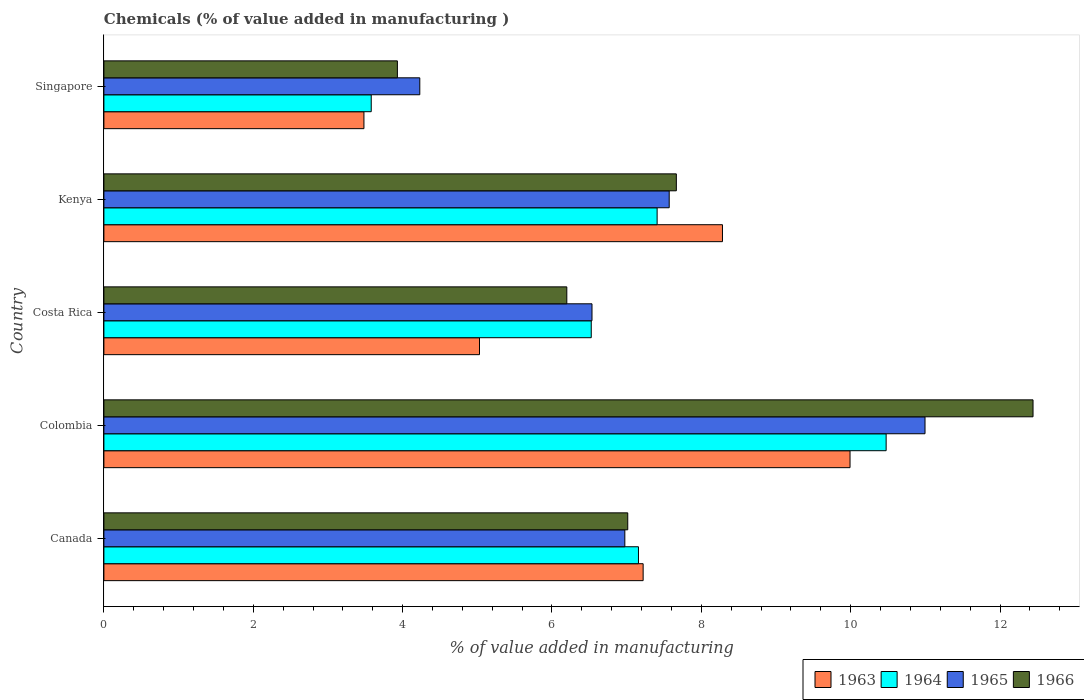How many different coloured bars are there?
Offer a very short reply. 4. How many groups of bars are there?
Make the answer very short. 5. How many bars are there on the 1st tick from the bottom?
Provide a short and direct response. 4. What is the label of the 2nd group of bars from the top?
Provide a succinct answer. Kenya. What is the value added in manufacturing chemicals in 1964 in Canada?
Provide a short and direct response. 7.16. Across all countries, what is the maximum value added in manufacturing chemicals in 1966?
Make the answer very short. 12.44. Across all countries, what is the minimum value added in manufacturing chemicals in 1966?
Your answer should be very brief. 3.93. In which country was the value added in manufacturing chemicals in 1966 minimum?
Your answer should be compact. Singapore. What is the total value added in manufacturing chemicals in 1963 in the graph?
Make the answer very short. 34.01. What is the difference between the value added in manufacturing chemicals in 1963 in Colombia and that in Costa Rica?
Your response must be concise. 4.96. What is the difference between the value added in manufacturing chemicals in 1964 in Costa Rica and the value added in manufacturing chemicals in 1965 in Canada?
Make the answer very short. -0.45. What is the average value added in manufacturing chemicals in 1966 per country?
Your response must be concise. 7.45. What is the difference between the value added in manufacturing chemicals in 1964 and value added in manufacturing chemicals in 1966 in Kenya?
Give a very brief answer. -0.26. In how many countries, is the value added in manufacturing chemicals in 1964 greater than 7.2 %?
Make the answer very short. 2. What is the ratio of the value added in manufacturing chemicals in 1965 in Canada to that in Costa Rica?
Make the answer very short. 1.07. What is the difference between the highest and the second highest value added in manufacturing chemicals in 1966?
Keep it short and to the point. 4.78. What is the difference between the highest and the lowest value added in manufacturing chemicals in 1963?
Ensure brevity in your answer.  6.51. Is the sum of the value added in manufacturing chemicals in 1966 in Canada and Colombia greater than the maximum value added in manufacturing chemicals in 1964 across all countries?
Your answer should be very brief. Yes. Is it the case that in every country, the sum of the value added in manufacturing chemicals in 1964 and value added in manufacturing chemicals in 1966 is greater than the sum of value added in manufacturing chemicals in 1965 and value added in manufacturing chemicals in 1963?
Ensure brevity in your answer.  No. What does the 1st bar from the top in Costa Rica represents?
Offer a terse response. 1966. What does the 4th bar from the bottom in Singapore represents?
Your response must be concise. 1966. Is it the case that in every country, the sum of the value added in manufacturing chemicals in 1965 and value added in manufacturing chemicals in 1964 is greater than the value added in manufacturing chemicals in 1963?
Provide a succinct answer. Yes. Are all the bars in the graph horizontal?
Your response must be concise. Yes. What is the difference between two consecutive major ticks on the X-axis?
Make the answer very short. 2. Are the values on the major ticks of X-axis written in scientific E-notation?
Offer a terse response. No. Does the graph contain grids?
Offer a terse response. No. Where does the legend appear in the graph?
Offer a very short reply. Bottom right. What is the title of the graph?
Provide a succinct answer. Chemicals (% of value added in manufacturing ). Does "2010" appear as one of the legend labels in the graph?
Make the answer very short. No. What is the label or title of the X-axis?
Make the answer very short. % of value added in manufacturing. What is the % of value added in manufacturing in 1963 in Canada?
Provide a short and direct response. 7.22. What is the % of value added in manufacturing of 1964 in Canada?
Provide a short and direct response. 7.16. What is the % of value added in manufacturing of 1965 in Canada?
Ensure brevity in your answer.  6.98. What is the % of value added in manufacturing of 1966 in Canada?
Keep it short and to the point. 7.01. What is the % of value added in manufacturing of 1963 in Colombia?
Your answer should be very brief. 9.99. What is the % of value added in manufacturing of 1964 in Colombia?
Your answer should be very brief. 10.47. What is the % of value added in manufacturing in 1965 in Colombia?
Make the answer very short. 10.99. What is the % of value added in manufacturing in 1966 in Colombia?
Ensure brevity in your answer.  12.44. What is the % of value added in manufacturing in 1963 in Costa Rica?
Offer a terse response. 5.03. What is the % of value added in manufacturing in 1964 in Costa Rica?
Your answer should be compact. 6.53. What is the % of value added in manufacturing in 1965 in Costa Rica?
Provide a succinct answer. 6.54. What is the % of value added in manufacturing of 1966 in Costa Rica?
Keep it short and to the point. 6.2. What is the % of value added in manufacturing of 1963 in Kenya?
Your answer should be very brief. 8.28. What is the % of value added in manufacturing in 1964 in Kenya?
Offer a very short reply. 7.41. What is the % of value added in manufacturing in 1965 in Kenya?
Provide a short and direct response. 7.57. What is the % of value added in manufacturing of 1966 in Kenya?
Keep it short and to the point. 7.67. What is the % of value added in manufacturing in 1963 in Singapore?
Offer a terse response. 3.48. What is the % of value added in manufacturing of 1964 in Singapore?
Your response must be concise. 3.58. What is the % of value added in manufacturing in 1965 in Singapore?
Offer a very short reply. 4.23. What is the % of value added in manufacturing of 1966 in Singapore?
Your response must be concise. 3.93. Across all countries, what is the maximum % of value added in manufacturing of 1963?
Your answer should be compact. 9.99. Across all countries, what is the maximum % of value added in manufacturing of 1964?
Offer a very short reply. 10.47. Across all countries, what is the maximum % of value added in manufacturing in 1965?
Your answer should be very brief. 10.99. Across all countries, what is the maximum % of value added in manufacturing of 1966?
Provide a short and direct response. 12.44. Across all countries, what is the minimum % of value added in manufacturing of 1963?
Offer a very short reply. 3.48. Across all countries, what is the minimum % of value added in manufacturing in 1964?
Provide a succinct answer. 3.58. Across all countries, what is the minimum % of value added in manufacturing of 1965?
Give a very brief answer. 4.23. Across all countries, what is the minimum % of value added in manufacturing of 1966?
Your answer should be very brief. 3.93. What is the total % of value added in manufacturing in 1963 in the graph?
Offer a terse response. 34.01. What is the total % of value added in manufacturing of 1964 in the graph?
Ensure brevity in your answer.  35.15. What is the total % of value added in manufacturing in 1965 in the graph?
Your answer should be compact. 36.31. What is the total % of value added in manufacturing in 1966 in the graph?
Offer a very short reply. 37.25. What is the difference between the % of value added in manufacturing of 1963 in Canada and that in Colombia?
Keep it short and to the point. -2.77. What is the difference between the % of value added in manufacturing of 1964 in Canada and that in Colombia?
Keep it short and to the point. -3.32. What is the difference between the % of value added in manufacturing of 1965 in Canada and that in Colombia?
Offer a terse response. -4.02. What is the difference between the % of value added in manufacturing of 1966 in Canada and that in Colombia?
Offer a very short reply. -5.43. What is the difference between the % of value added in manufacturing of 1963 in Canada and that in Costa Rica?
Offer a very short reply. 2.19. What is the difference between the % of value added in manufacturing of 1964 in Canada and that in Costa Rica?
Make the answer very short. 0.63. What is the difference between the % of value added in manufacturing in 1965 in Canada and that in Costa Rica?
Ensure brevity in your answer.  0.44. What is the difference between the % of value added in manufacturing of 1966 in Canada and that in Costa Rica?
Provide a succinct answer. 0.82. What is the difference between the % of value added in manufacturing in 1963 in Canada and that in Kenya?
Offer a very short reply. -1.06. What is the difference between the % of value added in manufacturing of 1964 in Canada and that in Kenya?
Keep it short and to the point. -0.25. What is the difference between the % of value added in manufacturing of 1965 in Canada and that in Kenya?
Offer a terse response. -0.59. What is the difference between the % of value added in manufacturing of 1966 in Canada and that in Kenya?
Keep it short and to the point. -0.65. What is the difference between the % of value added in manufacturing in 1963 in Canada and that in Singapore?
Keep it short and to the point. 3.74. What is the difference between the % of value added in manufacturing in 1964 in Canada and that in Singapore?
Make the answer very short. 3.58. What is the difference between the % of value added in manufacturing in 1965 in Canada and that in Singapore?
Ensure brevity in your answer.  2.75. What is the difference between the % of value added in manufacturing of 1966 in Canada and that in Singapore?
Make the answer very short. 3.08. What is the difference between the % of value added in manufacturing of 1963 in Colombia and that in Costa Rica?
Your answer should be very brief. 4.96. What is the difference between the % of value added in manufacturing in 1964 in Colombia and that in Costa Rica?
Your answer should be very brief. 3.95. What is the difference between the % of value added in manufacturing in 1965 in Colombia and that in Costa Rica?
Keep it short and to the point. 4.46. What is the difference between the % of value added in manufacturing of 1966 in Colombia and that in Costa Rica?
Give a very brief answer. 6.24. What is the difference between the % of value added in manufacturing in 1963 in Colombia and that in Kenya?
Your answer should be compact. 1.71. What is the difference between the % of value added in manufacturing in 1964 in Colombia and that in Kenya?
Ensure brevity in your answer.  3.07. What is the difference between the % of value added in manufacturing of 1965 in Colombia and that in Kenya?
Offer a very short reply. 3.43. What is the difference between the % of value added in manufacturing of 1966 in Colombia and that in Kenya?
Your response must be concise. 4.78. What is the difference between the % of value added in manufacturing of 1963 in Colombia and that in Singapore?
Provide a succinct answer. 6.51. What is the difference between the % of value added in manufacturing in 1964 in Colombia and that in Singapore?
Your response must be concise. 6.89. What is the difference between the % of value added in manufacturing in 1965 in Colombia and that in Singapore?
Give a very brief answer. 6.76. What is the difference between the % of value added in manufacturing in 1966 in Colombia and that in Singapore?
Keep it short and to the point. 8.51. What is the difference between the % of value added in manufacturing in 1963 in Costa Rica and that in Kenya?
Offer a very short reply. -3.25. What is the difference between the % of value added in manufacturing in 1964 in Costa Rica and that in Kenya?
Your answer should be compact. -0.88. What is the difference between the % of value added in manufacturing in 1965 in Costa Rica and that in Kenya?
Give a very brief answer. -1.03. What is the difference between the % of value added in manufacturing of 1966 in Costa Rica and that in Kenya?
Keep it short and to the point. -1.47. What is the difference between the % of value added in manufacturing in 1963 in Costa Rica and that in Singapore?
Make the answer very short. 1.55. What is the difference between the % of value added in manufacturing of 1964 in Costa Rica and that in Singapore?
Offer a terse response. 2.95. What is the difference between the % of value added in manufacturing in 1965 in Costa Rica and that in Singapore?
Offer a terse response. 2.31. What is the difference between the % of value added in manufacturing of 1966 in Costa Rica and that in Singapore?
Keep it short and to the point. 2.27. What is the difference between the % of value added in manufacturing of 1963 in Kenya and that in Singapore?
Your answer should be compact. 4.8. What is the difference between the % of value added in manufacturing of 1964 in Kenya and that in Singapore?
Provide a succinct answer. 3.83. What is the difference between the % of value added in manufacturing of 1965 in Kenya and that in Singapore?
Make the answer very short. 3.34. What is the difference between the % of value added in manufacturing of 1966 in Kenya and that in Singapore?
Give a very brief answer. 3.74. What is the difference between the % of value added in manufacturing in 1963 in Canada and the % of value added in manufacturing in 1964 in Colombia?
Give a very brief answer. -3.25. What is the difference between the % of value added in manufacturing of 1963 in Canada and the % of value added in manufacturing of 1965 in Colombia?
Provide a succinct answer. -3.77. What is the difference between the % of value added in manufacturing in 1963 in Canada and the % of value added in manufacturing in 1966 in Colombia?
Keep it short and to the point. -5.22. What is the difference between the % of value added in manufacturing of 1964 in Canada and the % of value added in manufacturing of 1965 in Colombia?
Your answer should be compact. -3.84. What is the difference between the % of value added in manufacturing of 1964 in Canada and the % of value added in manufacturing of 1966 in Colombia?
Ensure brevity in your answer.  -5.28. What is the difference between the % of value added in manufacturing of 1965 in Canada and the % of value added in manufacturing of 1966 in Colombia?
Your response must be concise. -5.47. What is the difference between the % of value added in manufacturing in 1963 in Canada and the % of value added in manufacturing in 1964 in Costa Rica?
Provide a short and direct response. 0.69. What is the difference between the % of value added in manufacturing in 1963 in Canada and the % of value added in manufacturing in 1965 in Costa Rica?
Your response must be concise. 0.68. What is the difference between the % of value added in manufacturing of 1963 in Canada and the % of value added in manufacturing of 1966 in Costa Rica?
Your response must be concise. 1.02. What is the difference between the % of value added in manufacturing of 1964 in Canada and the % of value added in manufacturing of 1965 in Costa Rica?
Ensure brevity in your answer.  0.62. What is the difference between the % of value added in manufacturing of 1964 in Canada and the % of value added in manufacturing of 1966 in Costa Rica?
Ensure brevity in your answer.  0.96. What is the difference between the % of value added in manufacturing in 1965 in Canada and the % of value added in manufacturing in 1966 in Costa Rica?
Your answer should be compact. 0.78. What is the difference between the % of value added in manufacturing of 1963 in Canada and the % of value added in manufacturing of 1964 in Kenya?
Your response must be concise. -0.19. What is the difference between the % of value added in manufacturing of 1963 in Canada and the % of value added in manufacturing of 1965 in Kenya?
Provide a short and direct response. -0.35. What is the difference between the % of value added in manufacturing in 1963 in Canada and the % of value added in manufacturing in 1966 in Kenya?
Provide a short and direct response. -0.44. What is the difference between the % of value added in manufacturing of 1964 in Canada and the % of value added in manufacturing of 1965 in Kenya?
Your answer should be very brief. -0.41. What is the difference between the % of value added in manufacturing in 1964 in Canada and the % of value added in manufacturing in 1966 in Kenya?
Keep it short and to the point. -0.51. What is the difference between the % of value added in manufacturing of 1965 in Canada and the % of value added in manufacturing of 1966 in Kenya?
Your answer should be very brief. -0.69. What is the difference between the % of value added in manufacturing of 1963 in Canada and the % of value added in manufacturing of 1964 in Singapore?
Offer a very short reply. 3.64. What is the difference between the % of value added in manufacturing of 1963 in Canada and the % of value added in manufacturing of 1965 in Singapore?
Your answer should be compact. 2.99. What is the difference between the % of value added in manufacturing of 1963 in Canada and the % of value added in manufacturing of 1966 in Singapore?
Provide a short and direct response. 3.29. What is the difference between the % of value added in manufacturing of 1964 in Canada and the % of value added in manufacturing of 1965 in Singapore?
Provide a succinct answer. 2.93. What is the difference between the % of value added in manufacturing of 1964 in Canada and the % of value added in manufacturing of 1966 in Singapore?
Your response must be concise. 3.23. What is the difference between the % of value added in manufacturing in 1965 in Canada and the % of value added in manufacturing in 1966 in Singapore?
Make the answer very short. 3.05. What is the difference between the % of value added in manufacturing in 1963 in Colombia and the % of value added in manufacturing in 1964 in Costa Rica?
Offer a terse response. 3.47. What is the difference between the % of value added in manufacturing in 1963 in Colombia and the % of value added in manufacturing in 1965 in Costa Rica?
Ensure brevity in your answer.  3.46. What is the difference between the % of value added in manufacturing in 1963 in Colombia and the % of value added in manufacturing in 1966 in Costa Rica?
Offer a very short reply. 3.79. What is the difference between the % of value added in manufacturing of 1964 in Colombia and the % of value added in manufacturing of 1965 in Costa Rica?
Offer a very short reply. 3.94. What is the difference between the % of value added in manufacturing of 1964 in Colombia and the % of value added in manufacturing of 1966 in Costa Rica?
Give a very brief answer. 4.28. What is the difference between the % of value added in manufacturing in 1965 in Colombia and the % of value added in manufacturing in 1966 in Costa Rica?
Ensure brevity in your answer.  4.8. What is the difference between the % of value added in manufacturing in 1963 in Colombia and the % of value added in manufacturing in 1964 in Kenya?
Provide a short and direct response. 2.58. What is the difference between the % of value added in manufacturing in 1963 in Colombia and the % of value added in manufacturing in 1965 in Kenya?
Provide a succinct answer. 2.42. What is the difference between the % of value added in manufacturing of 1963 in Colombia and the % of value added in manufacturing of 1966 in Kenya?
Provide a succinct answer. 2.33. What is the difference between the % of value added in manufacturing in 1964 in Colombia and the % of value added in manufacturing in 1965 in Kenya?
Give a very brief answer. 2.9. What is the difference between the % of value added in manufacturing of 1964 in Colombia and the % of value added in manufacturing of 1966 in Kenya?
Keep it short and to the point. 2.81. What is the difference between the % of value added in manufacturing of 1965 in Colombia and the % of value added in manufacturing of 1966 in Kenya?
Keep it short and to the point. 3.33. What is the difference between the % of value added in manufacturing in 1963 in Colombia and the % of value added in manufacturing in 1964 in Singapore?
Keep it short and to the point. 6.41. What is the difference between the % of value added in manufacturing in 1963 in Colombia and the % of value added in manufacturing in 1965 in Singapore?
Ensure brevity in your answer.  5.76. What is the difference between the % of value added in manufacturing in 1963 in Colombia and the % of value added in manufacturing in 1966 in Singapore?
Your answer should be very brief. 6.06. What is the difference between the % of value added in manufacturing of 1964 in Colombia and the % of value added in manufacturing of 1965 in Singapore?
Ensure brevity in your answer.  6.24. What is the difference between the % of value added in manufacturing in 1964 in Colombia and the % of value added in manufacturing in 1966 in Singapore?
Ensure brevity in your answer.  6.54. What is the difference between the % of value added in manufacturing in 1965 in Colombia and the % of value added in manufacturing in 1966 in Singapore?
Provide a succinct answer. 7.07. What is the difference between the % of value added in manufacturing in 1963 in Costa Rica and the % of value added in manufacturing in 1964 in Kenya?
Provide a short and direct response. -2.38. What is the difference between the % of value added in manufacturing of 1963 in Costa Rica and the % of value added in manufacturing of 1965 in Kenya?
Give a very brief answer. -2.54. What is the difference between the % of value added in manufacturing in 1963 in Costa Rica and the % of value added in manufacturing in 1966 in Kenya?
Your response must be concise. -2.64. What is the difference between the % of value added in manufacturing of 1964 in Costa Rica and the % of value added in manufacturing of 1965 in Kenya?
Ensure brevity in your answer.  -1.04. What is the difference between the % of value added in manufacturing in 1964 in Costa Rica and the % of value added in manufacturing in 1966 in Kenya?
Ensure brevity in your answer.  -1.14. What is the difference between the % of value added in manufacturing in 1965 in Costa Rica and the % of value added in manufacturing in 1966 in Kenya?
Provide a succinct answer. -1.13. What is the difference between the % of value added in manufacturing in 1963 in Costa Rica and the % of value added in manufacturing in 1964 in Singapore?
Offer a very short reply. 1.45. What is the difference between the % of value added in manufacturing in 1963 in Costa Rica and the % of value added in manufacturing in 1965 in Singapore?
Offer a very short reply. 0.8. What is the difference between the % of value added in manufacturing in 1963 in Costa Rica and the % of value added in manufacturing in 1966 in Singapore?
Give a very brief answer. 1.1. What is the difference between the % of value added in manufacturing of 1964 in Costa Rica and the % of value added in manufacturing of 1965 in Singapore?
Provide a succinct answer. 2.3. What is the difference between the % of value added in manufacturing in 1964 in Costa Rica and the % of value added in manufacturing in 1966 in Singapore?
Keep it short and to the point. 2.6. What is the difference between the % of value added in manufacturing of 1965 in Costa Rica and the % of value added in manufacturing of 1966 in Singapore?
Ensure brevity in your answer.  2.61. What is the difference between the % of value added in manufacturing of 1963 in Kenya and the % of value added in manufacturing of 1964 in Singapore?
Your answer should be very brief. 4.7. What is the difference between the % of value added in manufacturing in 1963 in Kenya and the % of value added in manufacturing in 1965 in Singapore?
Ensure brevity in your answer.  4.05. What is the difference between the % of value added in manufacturing in 1963 in Kenya and the % of value added in manufacturing in 1966 in Singapore?
Give a very brief answer. 4.35. What is the difference between the % of value added in manufacturing in 1964 in Kenya and the % of value added in manufacturing in 1965 in Singapore?
Provide a succinct answer. 3.18. What is the difference between the % of value added in manufacturing of 1964 in Kenya and the % of value added in manufacturing of 1966 in Singapore?
Give a very brief answer. 3.48. What is the difference between the % of value added in manufacturing in 1965 in Kenya and the % of value added in manufacturing in 1966 in Singapore?
Offer a terse response. 3.64. What is the average % of value added in manufacturing of 1963 per country?
Keep it short and to the point. 6.8. What is the average % of value added in manufacturing of 1964 per country?
Give a very brief answer. 7.03. What is the average % of value added in manufacturing of 1965 per country?
Make the answer very short. 7.26. What is the average % of value added in manufacturing in 1966 per country?
Your response must be concise. 7.45. What is the difference between the % of value added in manufacturing of 1963 and % of value added in manufacturing of 1964 in Canada?
Offer a terse response. 0.06. What is the difference between the % of value added in manufacturing of 1963 and % of value added in manufacturing of 1965 in Canada?
Provide a succinct answer. 0.25. What is the difference between the % of value added in manufacturing of 1963 and % of value added in manufacturing of 1966 in Canada?
Your answer should be very brief. 0.21. What is the difference between the % of value added in manufacturing in 1964 and % of value added in manufacturing in 1965 in Canada?
Your response must be concise. 0.18. What is the difference between the % of value added in manufacturing in 1964 and % of value added in manufacturing in 1966 in Canada?
Give a very brief answer. 0.14. What is the difference between the % of value added in manufacturing of 1965 and % of value added in manufacturing of 1966 in Canada?
Your answer should be very brief. -0.04. What is the difference between the % of value added in manufacturing in 1963 and % of value added in manufacturing in 1964 in Colombia?
Ensure brevity in your answer.  -0.48. What is the difference between the % of value added in manufacturing of 1963 and % of value added in manufacturing of 1965 in Colombia?
Offer a very short reply. -1. What is the difference between the % of value added in manufacturing of 1963 and % of value added in manufacturing of 1966 in Colombia?
Your answer should be very brief. -2.45. What is the difference between the % of value added in manufacturing of 1964 and % of value added in manufacturing of 1965 in Colombia?
Give a very brief answer. -0.52. What is the difference between the % of value added in manufacturing in 1964 and % of value added in manufacturing in 1966 in Colombia?
Provide a short and direct response. -1.97. What is the difference between the % of value added in manufacturing of 1965 and % of value added in manufacturing of 1966 in Colombia?
Your response must be concise. -1.45. What is the difference between the % of value added in manufacturing of 1963 and % of value added in manufacturing of 1964 in Costa Rica?
Provide a short and direct response. -1.5. What is the difference between the % of value added in manufacturing of 1963 and % of value added in manufacturing of 1965 in Costa Rica?
Offer a terse response. -1.51. What is the difference between the % of value added in manufacturing of 1963 and % of value added in manufacturing of 1966 in Costa Rica?
Your answer should be very brief. -1.17. What is the difference between the % of value added in manufacturing in 1964 and % of value added in manufacturing in 1965 in Costa Rica?
Your response must be concise. -0.01. What is the difference between the % of value added in manufacturing in 1964 and % of value added in manufacturing in 1966 in Costa Rica?
Offer a terse response. 0.33. What is the difference between the % of value added in manufacturing in 1965 and % of value added in manufacturing in 1966 in Costa Rica?
Give a very brief answer. 0.34. What is the difference between the % of value added in manufacturing of 1963 and % of value added in manufacturing of 1964 in Kenya?
Provide a succinct answer. 0.87. What is the difference between the % of value added in manufacturing of 1963 and % of value added in manufacturing of 1965 in Kenya?
Your answer should be compact. 0.71. What is the difference between the % of value added in manufacturing of 1963 and % of value added in manufacturing of 1966 in Kenya?
Provide a short and direct response. 0.62. What is the difference between the % of value added in manufacturing in 1964 and % of value added in manufacturing in 1965 in Kenya?
Provide a short and direct response. -0.16. What is the difference between the % of value added in manufacturing of 1964 and % of value added in manufacturing of 1966 in Kenya?
Provide a short and direct response. -0.26. What is the difference between the % of value added in manufacturing in 1965 and % of value added in manufacturing in 1966 in Kenya?
Keep it short and to the point. -0.1. What is the difference between the % of value added in manufacturing in 1963 and % of value added in manufacturing in 1964 in Singapore?
Offer a very short reply. -0.1. What is the difference between the % of value added in manufacturing of 1963 and % of value added in manufacturing of 1965 in Singapore?
Your response must be concise. -0.75. What is the difference between the % of value added in manufacturing in 1963 and % of value added in manufacturing in 1966 in Singapore?
Keep it short and to the point. -0.45. What is the difference between the % of value added in manufacturing of 1964 and % of value added in manufacturing of 1965 in Singapore?
Keep it short and to the point. -0.65. What is the difference between the % of value added in manufacturing of 1964 and % of value added in manufacturing of 1966 in Singapore?
Ensure brevity in your answer.  -0.35. What is the difference between the % of value added in manufacturing of 1965 and % of value added in manufacturing of 1966 in Singapore?
Offer a very short reply. 0.3. What is the ratio of the % of value added in manufacturing of 1963 in Canada to that in Colombia?
Make the answer very short. 0.72. What is the ratio of the % of value added in manufacturing in 1964 in Canada to that in Colombia?
Your answer should be very brief. 0.68. What is the ratio of the % of value added in manufacturing of 1965 in Canada to that in Colombia?
Offer a very short reply. 0.63. What is the ratio of the % of value added in manufacturing in 1966 in Canada to that in Colombia?
Make the answer very short. 0.56. What is the ratio of the % of value added in manufacturing of 1963 in Canada to that in Costa Rica?
Provide a succinct answer. 1.44. What is the ratio of the % of value added in manufacturing in 1964 in Canada to that in Costa Rica?
Offer a terse response. 1.1. What is the ratio of the % of value added in manufacturing in 1965 in Canada to that in Costa Rica?
Make the answer very short. 1.07. What is the ratio of the % of value added in manufacturing of 1966 in Canada to that in Costa Rica?
Ensure brevity in your answer.  1.13. What is the ratio of the % of value added in manufacturing in 1963 in Canada to that in Kenya?
Ensure brevity in your answer.  0.87. What is the ratio of the % of value added in manufacturing of 1964 in Canada to that in Kenya?
Your response must be concise. 0.97. What is the ratio of the % of value added in manufacturing in 1965 in Canada to that in Kenya?
Your answer should be very brief. 0.92. What is the ratio of the % of value added in manufacturing in 1966 in Canada to that in Kenya?
Provide a short and direct response. 0.92. What is the ratio of the % of value added in manufacturing in 1963 in Canada to that in Singapore?
Your response must be concise. 2.07. What is the ratio of the % of value added in manufacturing of 1964 in Canada to that in Singapore?
Ensure brevity in your answer.  2. What is the ratio of the % of value added in manufacturing in 1965 in Canada to that in Singapore?
Your response must be concise. 1.65. What is the ratio of the % of value added in manufacturing of 1966 in Canada to that in Singapore?
Give a very brief answer. 1.78. What is the ratio of the % of value added in manufacturing of 1963 in Colombia to that in Costa Rica?
Provide a succinct answer. 1.99. What is the ratio of the % of value added in manufacturing in 1964 in Colombia to that in Costa Rica?
Provide a short and direct response. 1.61. What is the ratio of the % of value added in manufacturing in 1965 in Colombia to that in Costa Rica?
Offer a very short reply. 1.68. What is the ratio of the % of value added in manufacturing in 1966 in Colombia to that in Costa Rica?
Offer a terse response. 2.01. What is the ratio of the % of value added in manufacturing in 1963 in Colombia to that in Kenya?
Offer a very short reply. 1.21. What is the ratio of the % of value added in manufacturing in 1964 in Colombia to that in Kenya?
Provide a succinct answer. 1.41. What is the ratio of the % of value added in manufacturing of 1965 in Colombia to that in Kenya?
Your response must be concise. 1.45. What is the ratio of the % of value added in manufacturing of 1966 in Colombia to that in Kenya?
Offer a terse response. 1.62. What is the ratio of the % of value added in manufacturing in 1963 in Colombia to that in Singapore?
Offer a terse response. 2.87. What is the ratio of the % of value added in manufacturing in 1964 in Colombia to that in Singapore?
Ensure brevity in your answer.  2.93. What is the ratio of the % of value added in manufacturing in 1965 in Colombia to that in Singapore?
Keep it short and to the point. 2.6. What is the ratio of the % of value added in manufacturing of 1966 in Colombia to that in Singapore?
Give a very brief answer. 3.17. What is the ratio of the % of value added in manufacturing in 1963 in Costa Rica to that in Kenya?
Make the answer very short. 0.61. What is the ratio of the % of value added in manufacturing of 1964 in Costa Rica to that in Kenya?
Your answer should be very brief. 0.88. What is the ratio of the % of value added in manufacturing in 1965 in Costa Rica to that in Kenya?
Make the answer very short. 0.86. What is the ratio of the % of value added in manufacturing in 1966 in Costa Rica to that in Kenya?
Provide a short and direct response. 0.81. What is the ratio of the % of value added in manufacturing in 1963 in Costa Rica to that in Singapore?
Make the answer very short. 1.44. What is the ratio of the % of value added in manufacturing of 1964 in Costa Rica to that in Singapore?
Ensure brevity in your answer.  1.82. What is the ratio of the % of value added in manufacturing in 1965 in Costa Rica to that in Singapore?
Your answer should be compact. 1.55. What is the ratio of the % of value added in manufacturing of 1966 in Costa Rica to that in Singapore?
Ensure brevity in your answer.  1.58. What is the ratio of the % of value added in manufacturing of 1963 in Kenya to that in Singapore?
Provide a succinct answer. 2.38. What is the ratio of the % of value added in manufacturing in 1964 in Kenya to that in Singapore?
Make the answer very short. 2.07. What is the ratio of the % of value added in manufacturing in 1965 in Kenya to that in Singapore?
Provide a succinct answer. 1.79. What is the ratio of the % of value added in manufacturing in 1966 in Kenya to that in Singapore?
Make the answer very short. 1.95. What is the difference between the highest and the second highest % of value added in manufacturing in 1963?
Give a very brief answer. 1.71. What is the difference between the highest and the second highest % of value added in manufacturing of 1964?
Keep it short and to the point. 3.07. What is the difference between the highest and the second highest % of value added in manufacturing in 1965?
Your answer should be very brief. 3.43. What is the difference between the highest and the second highest % of value added in manufacturing of 1966?
Provide a succinct answer. 4.78. What is the difference between the highest and the lowest % of value added in manufacturing in 1963?
Offer a very short reply. 6.51. What is the difference between the highest and the lowest % of value added in manufacturing in 1964?
Offer a terse response. 6.89. What is the difference between the highest and the lowest % of value added in manufacturing in 1965?
Make the answer very short. 6.76. What is the difference between the highest and the lowest % of value added in manufacturing of 1966?
Give a very brief answer. 8.51. 